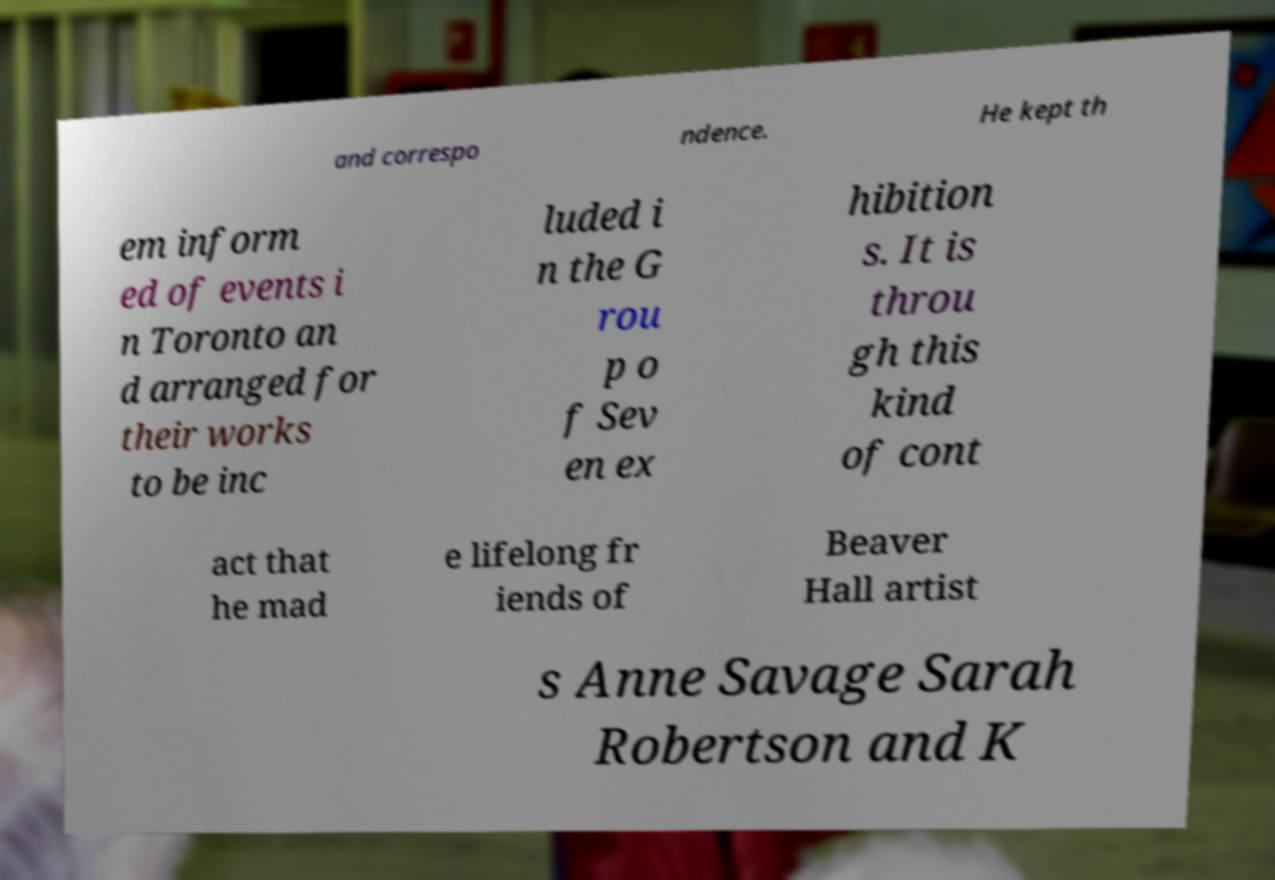Can you read and provide the text displayed in the image?This photo seems to have some interesting text. Can you extract and type it out for me? and correspo ndence. He kept th em inform ed of events i n Toronto an d arranged for their works to be inc luded i n the G rou p o f Sev en ex hibition s. It is throu gh this kind of cont act that he mad e lifelong fr iends of Beaver Hall artist s Anne Savage Sarah Robertson and K 